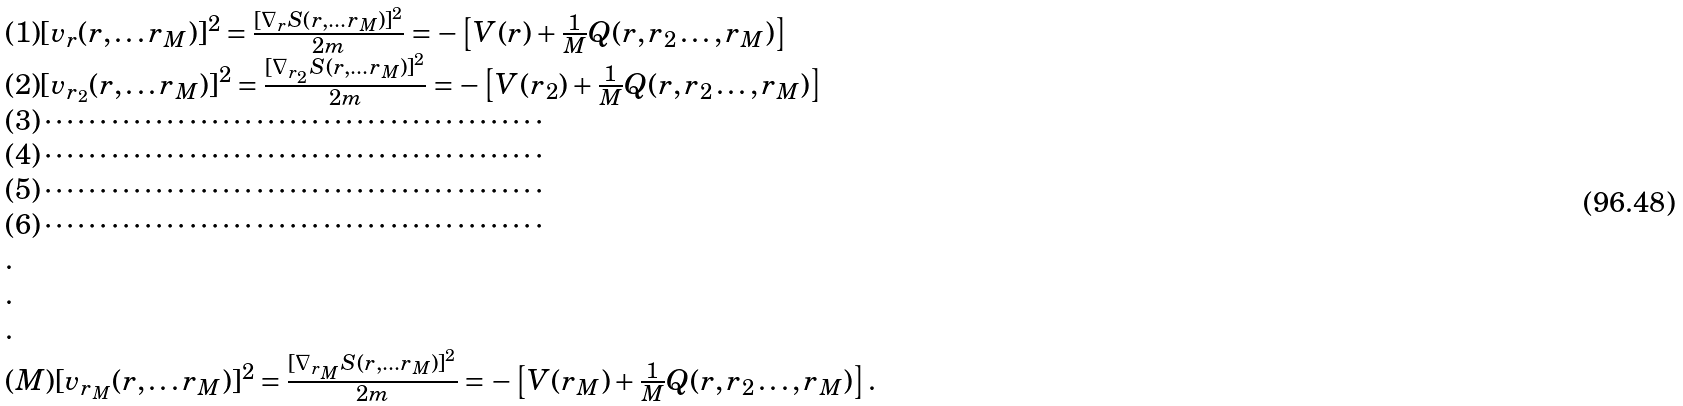<formula> <loc_0><loc_0><loc_500><loc_500>\begin{array} { l l } { ( 1 ) } [ { v } _ { r } ( { r , \dots r _ { M } } ) ] ^ { 2 } = \frac { [ \nabla _ { r } S ( { r , \dots r _ { M } } ) ] ^ { 2 } } { 2 m } = - \left [ V ( { r } ) + \frac { 1 } { M } Q ( { r , r _ { 2 } \dots , r _ { M } } ) \right ] \\ { ( 2 ) } [ { v } _ { r _ { 2 } } ( { r , \dots r _ { M } } ) ] ^ { 2 } = \frac { [ \nabla _ { r _ { 2 } } S ( { r , \dots r _ { M } } ) ] ^ { 2 } } { 2 m } = - \left [ V ( { r _ { 2 } } ) + \frac { 1 } { M } Q ( { r , r _ { 2 } \dots , r _ { M } } ) \right ] \\ { ( 3 ) } \cdots \cdots \cdots \cdots \cdots \cdots \cdots \cdots \cdots \cdots \cdots \cdots \cdots \cdots \cdots \\ { ( 4 ) } \cdots \cdots \cdots \cdots \cdots \cdots \cdots \cdots \cdots \cdots \cdots \cdots \cdots \cdots \cdots \\ { ( 5 ) } \cdots \cdots \cdots \cdots \cdots \cdots \cdots \cdots \cdots \cdots \cdots \cdots \cdots \cdots \cdots \\ { ( 6 ) } \cdots \cdots \cdots \cdots \cdots \cdots \cdots \cdots \cdots \cdots \cdots \cdots \cdots \cdots \cdots \\ . \\ . \\ . \\ { ( M ) } [ { v } _ { r _ { M } } ( { r , \dots r _ { M } } ) ] ^ { 2 } = \frac { [ \nabla _ { r _ { M } } S ( { r , \dots r _ { M } } ) ] ^ { 2 } } { 2 m } = - \left [ V ( { r _ { M } } ) + \frac { 1 } { M } Q ( { r , r _ { 2 } \dots , r _ { M } } ) \right ] . \end{array}</formula> 